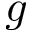<formula> <loc_0><loc_0><loc_500><loc_500>g</formula> 